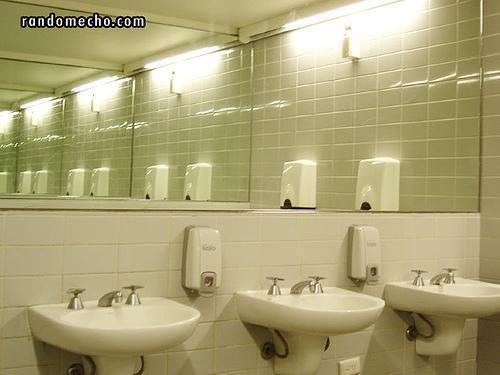How many sinks are there?
Give a very brief answer. 3. 